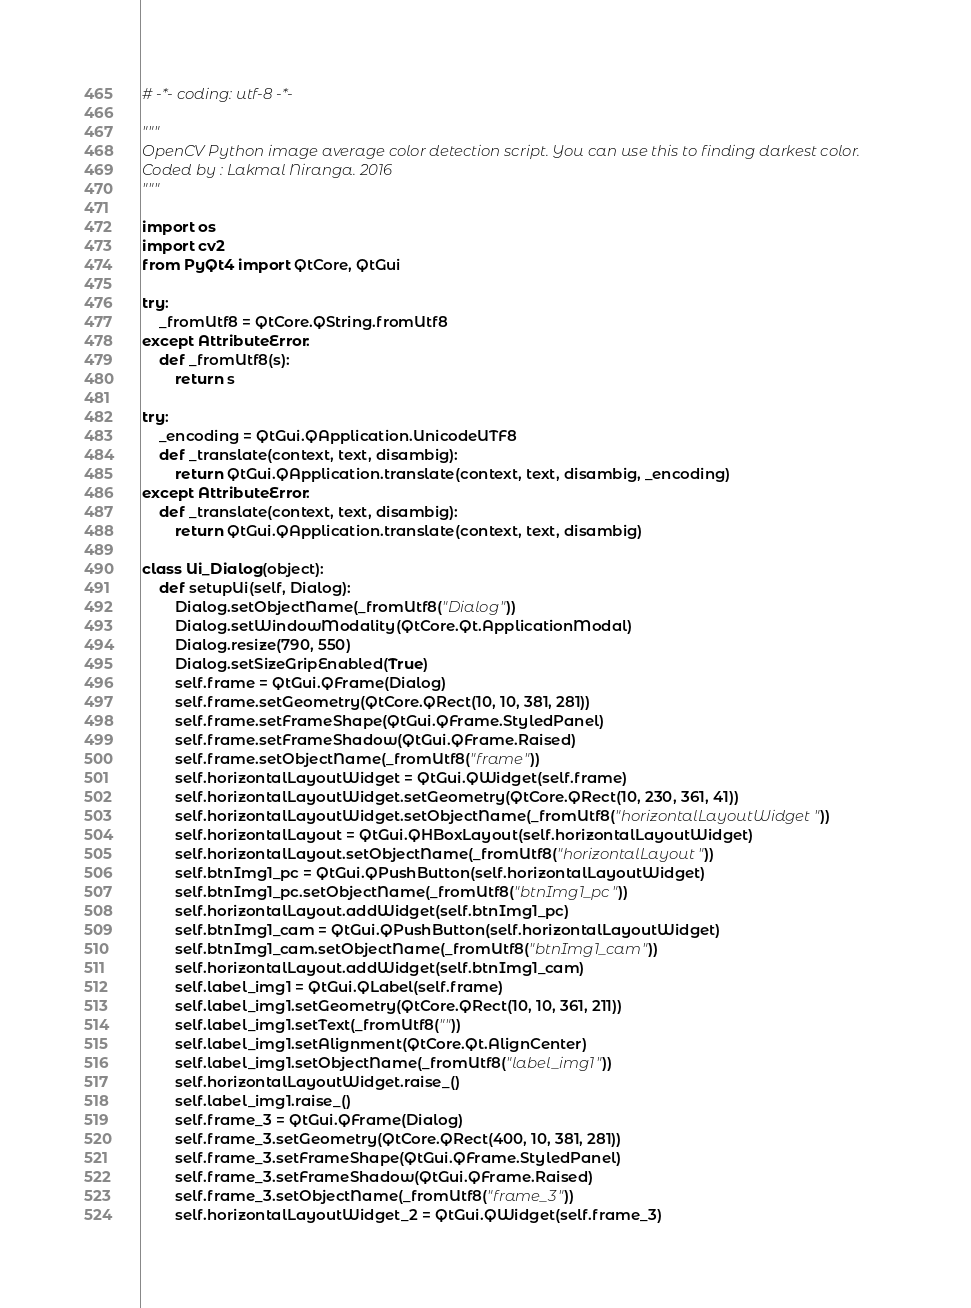Convert code to text. <code><loc_0><loc_0><loc_500><loc_500><_Python_># -*- coding: utf-8 -*-

"""
OpenCV Python image average color detection script. You can use this to finding darkest color.
Coded by : Lakmal Niranga. 2016
"""

import os
import cv2
from PyQt4 import QtCore, QtGui

try:
    _fromUtf8 = QtCore.QString.fromUtf8
except AttributeError:
    def _fromUtf8(s):
        return s

try:
    _encoding = QtGui.QApplication.UnicodeUTF8
    def _translate(context, text, disambig):
        return QtGui.QApplication.translate(context, text, disambig, _encoding)
except AttributeError:
    def _translate(context, text, disambig):
        return QtGui.QApplication.translate(context, text, disambig)

class Ui_Dialog(object):
    def setupUi(self, Dialog):
        Dialog.setObjectName(_fromUtf8("Dialog"))
        Dialog.setWindowModality(QtCore.Qt.ApplicationModal)
        Dialog.resize(790, 550)
        Dialog.setSizeGripEnabled(True)
        self.frame = QtGui.QFrame(Dialog)
        self.frame.setGeometry(QtCore.QRect(10, 10, 381, 281))
        self.frame.setFrameShape(QtGui.QFrame.StyledPanel)
        self.frame.setFrameShadow(QtGui.QFrame.Raised)
        self.frame.setObjectName(_fromUtf8("frame"))
        self.horizontalLayoutWidget = QtGui.QWidget(self.frame)
        self.horizontalLayoutWidget.setGeometry(QtCore.QRect(10, 230, 361, 41))
        self.horizontalLayoutWidget.setObjectName(_fromUtf8("horizontalLayoutWidget"))
        self.horizontalLayout = QtGui.QHBoxLayout(self.horizontalLayoutWidget)
        self.horizontalLayout.setObjectName(_fromUtf8("horizontalLayout"))
        self.btnImg1_pc = QtGui.QPushButton(self.horizontalLayoutWidget)
        self.btnImg1_pc.setObjectName(_fromUtf8("btnImg1_pc"))
        self.horizontalLayout.addWidget(self.btnImg1_pc)
        self.btnImg1_cam = QtGui.QPushButton(self.horizontalLayoutWidget)
        self.btnImg1_cam.setObjectName(_fromUtf8("btnImg1_cam"))
        self.horizontalLayout.addWidget(self.btnImg1_cam)
        self.label_img1 = QtGui.QLabel(self.frame)
        self.label_img1.setGeometry(QtCore.QRect(10, 10, 361, 211))
        self.label_img1.setText(_fromUtf8(""))
        self.label_img1.setAlignment(QtCore.Qt.AlignCenter)
        self.label_img1.setObjectName(_fromUtf8("label_img1"))
        self.horizontalLayoutWidget.raise_()
        self.label_img1.raise_()
        self.frame_3 = QtGui.QFrame(Dialog)
        self.frame_3.setGeometry(QtCore.QRect(400, 10, 381, 281))
        self.frame_3.setFrameShape(QtGui.QFrame.StyledPanel)
        self.frame_3.setFrameShadow(QtGui.QFrame.Raised)
        self.frame_3.setObjectName(_fromUtf8("frame_3"))
        self.horizontalLayoutWidget_2 = QtGui.QWidget(self.frame_3)</code> 